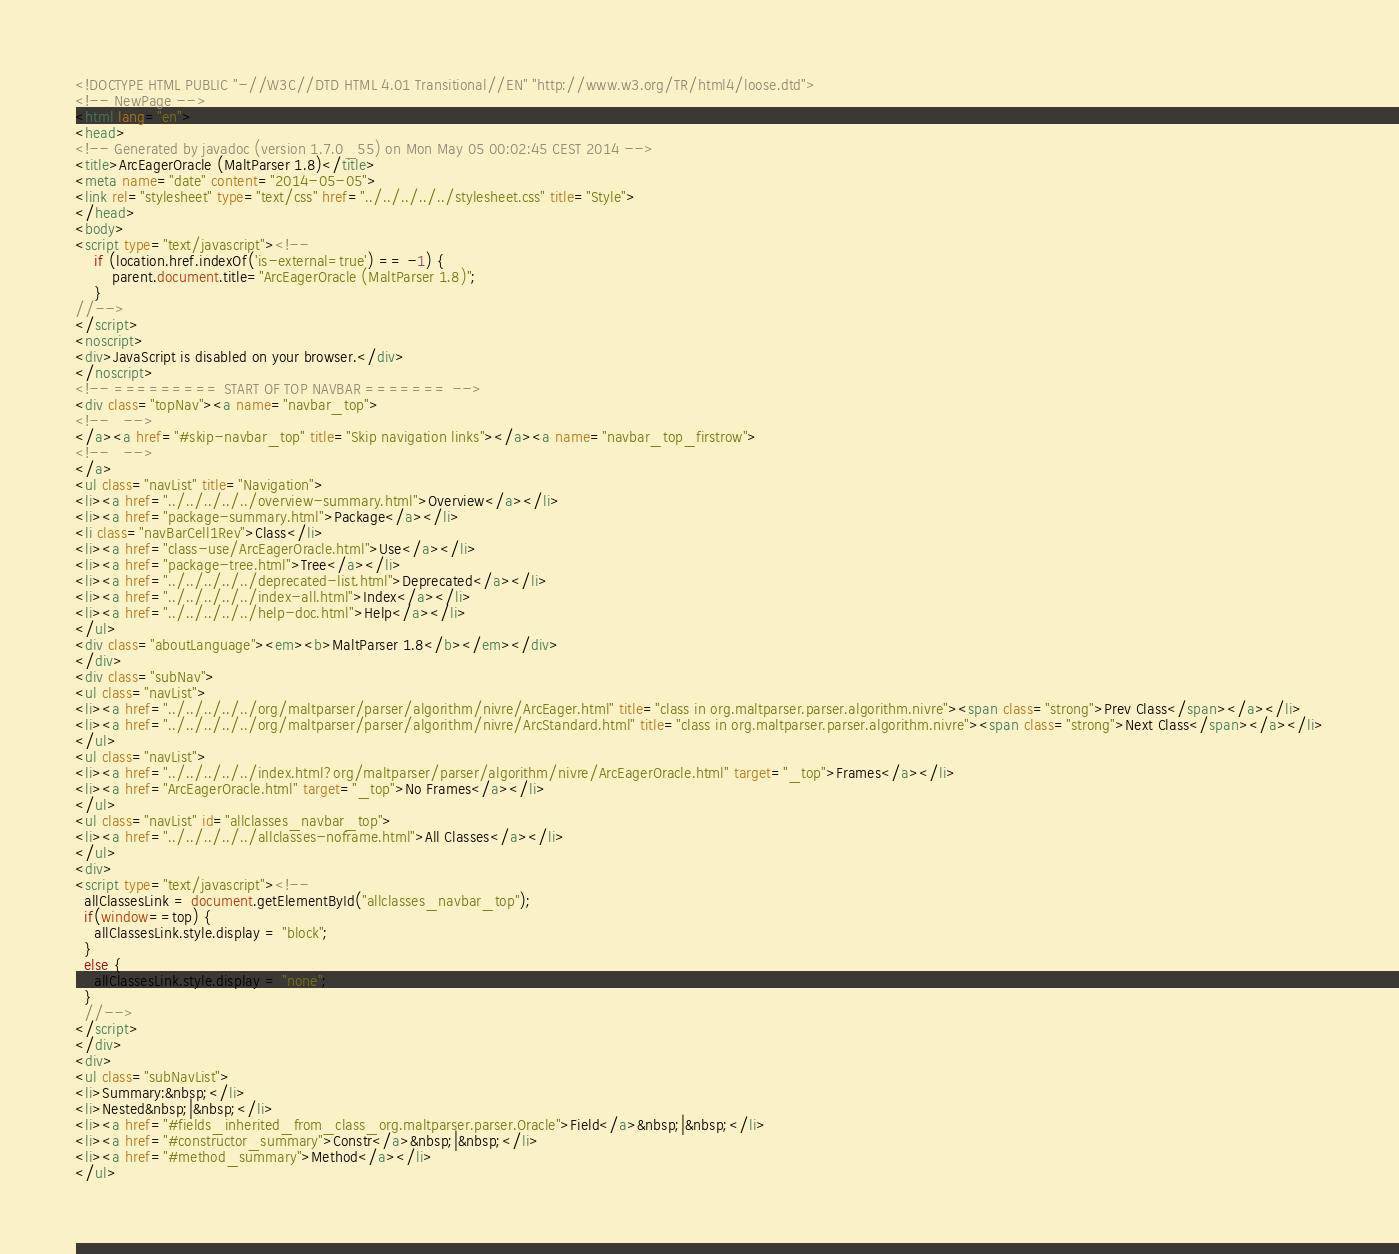<code> <loc_0><loc_0><loc_500><loc_500><_HTML_><!DOCTYPE HTML PUBLIC "-//W3C//DTD HTML 4.01 Transitional//EN" "http://www.w3.org/TR/html4/loose.dtd">
<!-- NewPage -->
<html lang="en">
<head>
<!-- Generated by javadoc (version 1.7.0_55) on Mon May 05 00:02:45 CEST 2014 -->
<title>ArcEagerOracle (MaltParser 1.8)</title>
<meta name="date" content="2014-05-05">
<link rel="stylesheet" type="text/css" href="../../../../../stylesheet.css" title="Style">
</head>
<body>
<script type="text/javascript"><!--
    if (location.href.indexOf('is-external=true') == -1) {
        parent.document.title="ArcEagerOracle (MaltParser 1.8)";
    }
//-->
</script>
<noscript>
<div>JavaScript is disabled on your browser.</div>
</noscript>
<!-- ========= START OF TOP NAVBAR ======= -->
<div class="topNav"><a name="navbar_top">
<!--   -->
</a><a href="#skip-navbar_top" title="Skip navigation links"></a><a name="navbar_top_firstrow">
<!--   -->
</a>
<ul class="navList" title="Navigation">
<li><a href="../../../../../overview-summary.html">Overview</a></li>
<li><a href="package-summary.html">Package</a></li>
<li class="navBarCell1Rev">Class</li>
<li><a href="class-use/ArcEagerOracle.html">Use</a></li>
<li><a href="package-tree.html">Tree</a></li>
<li><a href="../../../../../deprecated-list.html">Deprecated</a></li>
<li><a href="../../../../../index-all.html">Index</a></li>
<li><a href="../../../../../help-doc.html">Help</a></li>
</ul>
<div class="aboutLanguage"><em><b>MaltParser 1.8</b></em></div>
</div>
<div class="subNav">
<ul class="navList">
<li><a href="../../../../../org/maltparser/parser/algorithm/nivre/ArcEager.html" title="class in org.maltparser.parser.algorithm.nivre"><span class="strong">Prev Class</span></a></li>
<li><a href="../../../../../org/maltparser/parser/algorithm/nivre/ArcStandard.html" title="class in org.maltparser.parser.algorithm.nivre"><span class="strong">Next Class</span></a></li>
</ul>
<ul class="navList">
<li><a href="../../../../../index.html?org/maltparser/parser/algorithm/nivre/ArcEagerOracle.html" target="_top">Frames</a></li>
<li><a href="ArcEagerOracle.html" target="_top">No Frames</a></li>
</ul>
<ul class="navList" id="allclasses_navbar_top">
<li><a href="../../../../../allclasses-noframe.html">All Classes</a></li>
</ul>
<div>
<script type="text/javascript"><!--
  allClassesLink = document.getElementById("allclasses_navbar_top");
  if(window==top) {
    allClassesLink.style.display = "block";
  }
  else {
    allClassesLink.style.display = "none";
  }
  //-->
</script>
</div>
<div>
<ul class="subNavList">
<li>Summary:&nbsp;</li>
<li>Nested&nbsp;|&nbsp;</li>
<li><a href="#fields_inherited_from_class_org.maltparser.parser.Oracle">Field</a>&nbsp;|&nbsp;</li>
<li><a href="#constructor_summary">Constr</a>&nbsp;|&nbsp;</li>
<li><a href="#method_summary">Method</a></li>
</ul></code> 